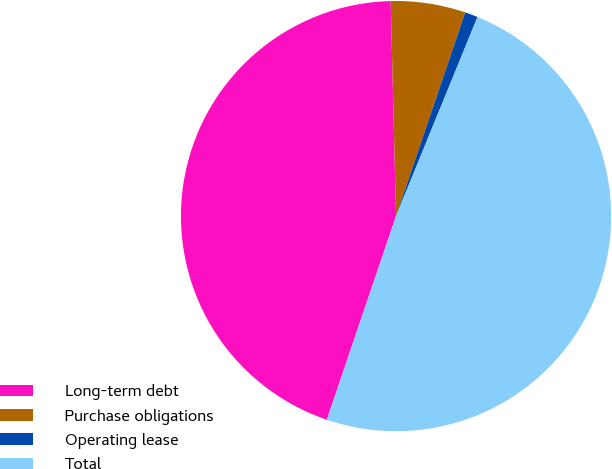<chart> <loc_0><loc_0><loc_500><loc_500><pie_chart><fcel>Long-term debt<fcel>Purchase obligations<fcel>Operating lease<fcel>Total<nl><fcel>44.39%<fcel>5.61%<fcel>0.97%<fcel>49.03%<nl></chart> 